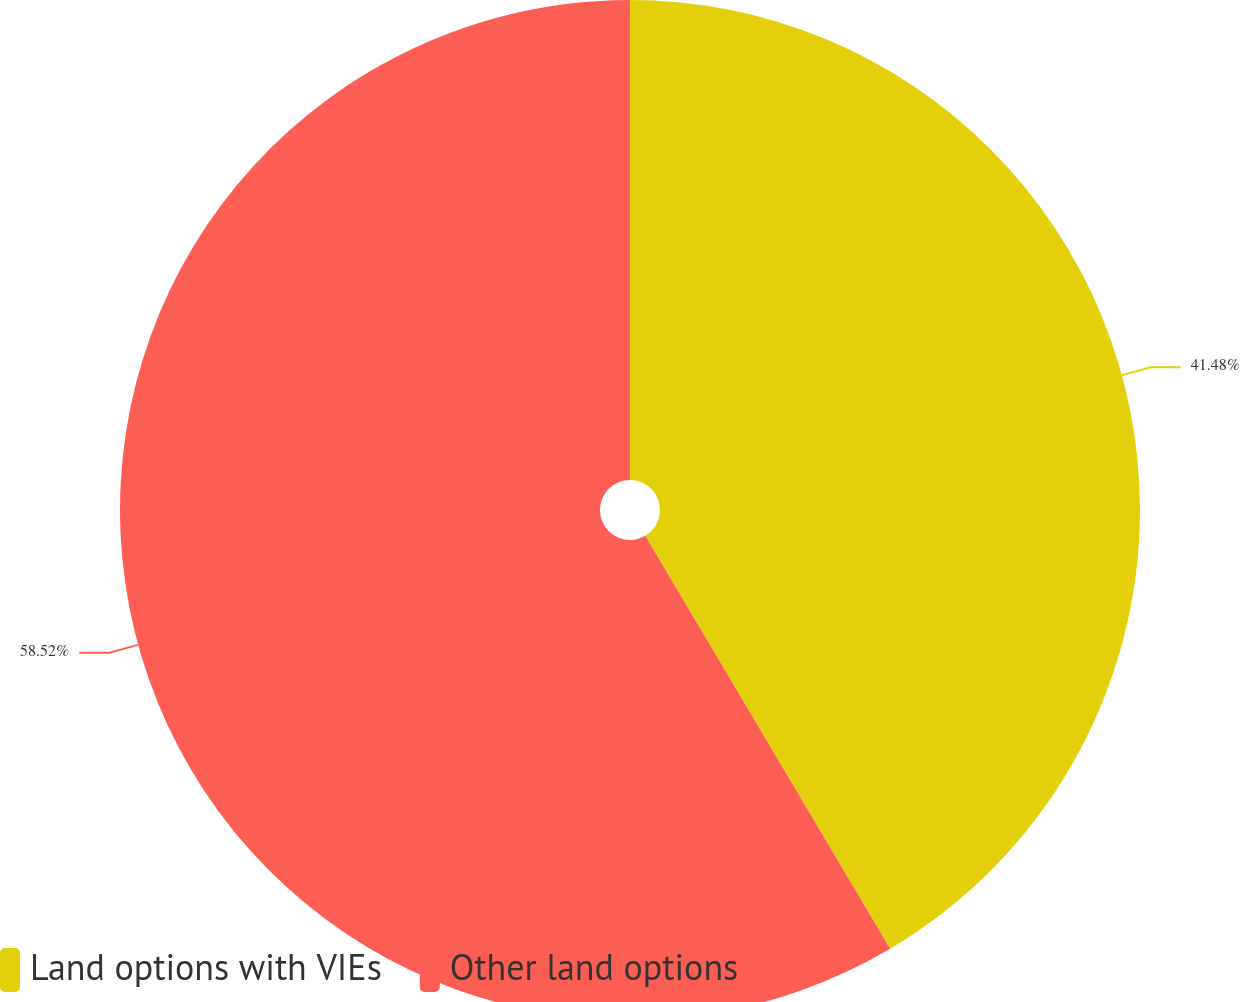<chart> <loc_0><loc_0><loc_500><loc_500><pie_chart><fcel>Land options with VIEs<fcel>Other land options<nl><fcel>41.48%<fcel>58.52%<nl></chart> 